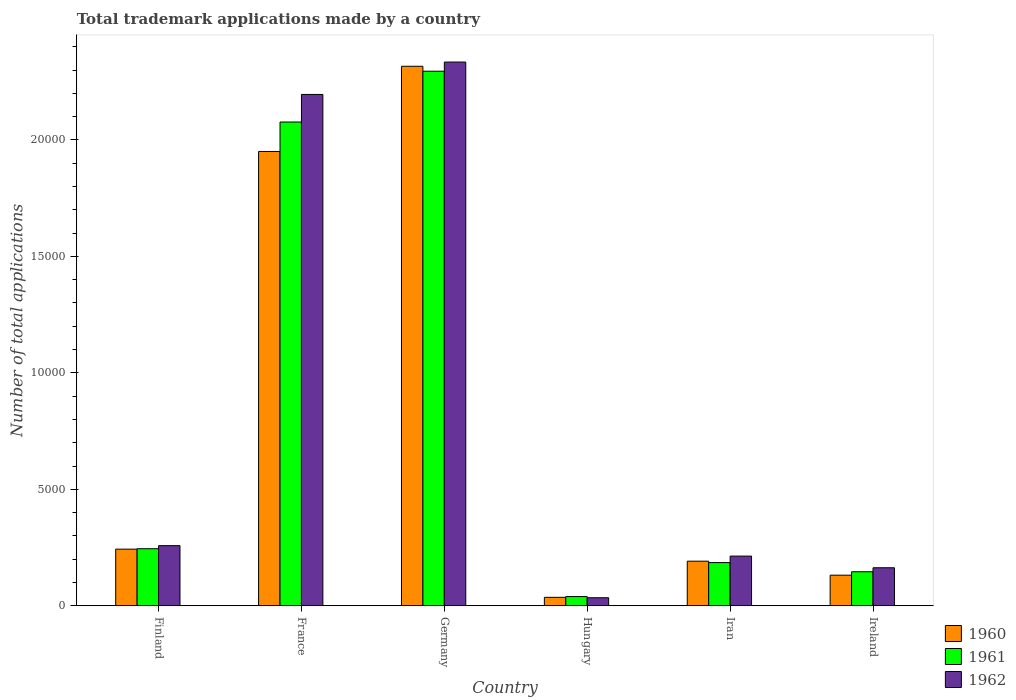Are the number of bars per tick equal to the number of legend labels?
Give a very brief answer. Yes. Are the number of bars on each tick of the X-axis equal?
Provide a short and direct response. Yes. How many bars are there on the 4th tick from the right?
Offer a very short reply. 3. What is the label of the 5th group of bars from the left?
Make the answer very short. Iran. What is the number of applications made by in 1962 in France?
Keep it short and to the point. 2.20e+04. Across all countries, what is the maximum number of applications made by in 1962?
Provide a short and direct response. 2.33e+04. Across all countries, what is the minimum number of applications made by in 1960?
Provide a succinct answer. 363. In which country was the number of applications made by in 1962 minimum?
Offer a very short reply. Hungary. What is the total number of applications made by in 1961 in the graph?
Your answer should be compact. 4.99e+04. What is the difference between the number of applications made by in 1960 in Germany and that in Ireland?
Give a very brief answer. 2.18e+04. What is the difference between the number of applications made by in 1961 in Finland and the number of applications made by in 1960 in Iran?
Give a very brief answer. 535. What is the average number of applications made by in 1960 per country?
Your answer should be compact. 8114.83. What is the difference between the number of applications made by of/in 1962 and number of applications made by of/in 1961 in Finland?
Keep it short and to the point. 132. In how many countries, is the number of applications made by in 1960 greater than 7000?
Your response must be concise. 2. What is the ratio of the number of applications made by in 1961 in Iran to that in Ireland?
Give a very brief answer. 1.27. Is the difference between the number of applications made by in 1962 in Germany and Iran greater than the difference between the number of applications made by in 1961 in Germany and Iran?
Ensure brevity in your answer.  Yes. What is the difference between the highest and the second highest number of applications made by in 1961?
Give a very brief answer. 1.83e+04. What is the difference between the highest and the lowest number of applications made by in 1960?
Make the answer very short. 2.28e+04. In how many countries, is the number of applications made by in 1960 greater than the average number of applications made by in 1960 taken over all countries?
Provide a short and direct response. 2. Is the sum of the number of applications made by in 1962 in France and Ireland greater than the maximum number of applications made by in 1960 across all countries?
Provide a short and direct response. Yes. What does the 2nd bar from the right in Iran represents?
Your response must be concise. 1961. Is it the case that in every country, the sum of the number of applications made by in 1962 and number of applications made by in 1960 is greater than the number of applications made by in 1961?
Make the answer very short. Yes. How many bars are there?
Provide a short and direct response. 18. Are all the bars in the graph horizontal?
Provide a succinct answer. No. Are the values on the major ticks of Y-axis written in scientific E-notation?
Your answer should be compact. No. Does the graph contain any zero values?
Keep it short and to the point. No. Does the graph contain grids?
Your answer should be very brief. No. Where does the legend appear in the graph?
Provide a short and direct response. Bottom right. How many legend labels are there?
Give a very brief answer. 3. What is the title of the graph?
Your answer should be compact. Total trademark applications made by a country. Does "2010" appear as one of the legend labels in the graph?
Your answer should be very brief. No. What is the label or title of the X-axis?
Your response must be concise. Country. What is the label or title of the Y-axis?
Your response must be concise. Number of total applications. What is the Number of total applications of 1960 in Finland?
Your answer should be very brief. 2432. What is the Number of total applications of 1961 in Finland?
Your response must be concise. 2450. What is the Number of total applications in 1962 in Finland?
Provide a short and direct response. 2582. What is the Number of total applications of 1960 in France?
Give a very brief answer. 1.95e+04. What is the Number of total applications in 1961 in France?
Provide a succinct answer. 2.08e+04. What is the Number of total applications of 1962 in France?
Your answer should be compact. 2.20e+04. What is the Number of total applications in 1960 in Germany?
Provide a succinct answer. 2.32e+04. What is the Number of total applications in 1961 in Germany?
Your response must be concise. 2.29e+04. What is the Number of total applications of 1962 in Germany?
Your answer should be compact. 2.33e+04. What is the Number of total applications in 1960 in Hungary?
Make the answer very short. 363. What is the Number of total applications of 1961 in Hungary?
Offer a terse response. 396. What is the Number of total applications of 1962 in Hungary?
Keep it short and to the point. 346. What is the Number of total applications of 1960 in Iran?
Offer a very short reply. 1915. What is the Number of total applications in 1961 in Iran?
Your answer should be compact. 1854. What is the Number of total applications in 1962 in Iran?
Offer a terse response. 2134. What is the Number of total applications in 1960 in Ireland?
Provide a short and direct response. 1314. What is the Number of total applications of 1961 in Ireland?
Your answer should be very brief. 1461. What is the Number of total applications of 1962 in Ireland?
Your answer should be compact. 1633. Across all countries, what is the maximum Number of total applications of 1960?
Your response must be concise. 2.32e+04. Across all countries, what is the maximum Number of total applications of 1961?
Provide a succinct answer. 2.29e+04. Across all countries, what is the maximum Number of total applications in 1962?
Make the answer very short. 2.33e+04. Across all countries, what is the minimum Number of total applications of 1960?
Make the answer very short. 363. Across all countries, what is the minimum Number of total applications in 1961?
Give a very brief answer. 396. Across all countries, what is the minimum Number of total applications in 1962?
Provide a short and direct response. 346. What is the total Number of total applications of 1960 in the graph?
Provide a short and direct response. 4.87e+04. What is the total Number of total applications of 1961 in the graph?
Your response must be concise. 4.99e+04. What is the total Number of total applications of 1962 in the graph?
Provide a succinct answer. 5.20e+04. What is the difference between the Number of total applications in 1960 in Finland and that in France?
Make the answer very short. -1.71e+04. What is the difference between the Number of total applications of 1961 in Finland and that in France?
Offer a very short reply. -1.83e+04. What is the difference between the Number of total applications of 1962 in Finland and that in France?
Provide a short and direct response. -1.94e+04. What is the difference between the Number of total applications of 1960 in Finland and that in Germany?
Your answer should be very brief. -2.07e+04. What is the difference between the Number of total applications of 1961 in Finland and that in Germany?
Make the answer very short. -2.05e+04. What is the difference between the Number of total applications of 1962 in Finland and that in Germany?
Keep it short and to the point. -2.08e+04. What is the difference between the Number of total applications in 1960 in Finland and that in Hungary?
Your response must be concise. 2069. What is the difference between the Number of total applications of 1961 in Finland and that in Hungary?
Provide a succinct answer. 2054. What is the difference between the Number of total applications of 1962 in Finland and that in Hungary?
Your answer should be very brief. 2236. What is the difference between the Number of total applications of 1960 in Finland and that in Iran?
Ensure brevity in your answer.  517. What is the difference between the Number of total applications in 1961 in Finland and that in Iran?
Provide a succinct answer. 596. What is the difference between the Number of total applications of 1962 in Finland and that in Iran?
Offer a terse response. 448. What is the difference between the Number of total applications in 1960 in Finland and that in Ireland?
Your answer should be very brief. 1118. What is the difference between the Number of total applications in 1961 in Finland and that in Ireland?
Make the answer very short. 989. What is the difference between the Number of total applications of 1962 in Finland and that in Ireland?
Provide a succinct answer. 949. What is the difference between the Number of total applications in 1960 in France and that in Germany?
Make the answer very short. -3657. What is the difference between the Number of total applications of 1961 in France and that in Germany?
Make the answer very short. -2181. What is the difference between the Number of total applications in 1962 in France and that in Germany?
Provide a short and direct response. -1390. What is the difference between the Number of total applications of 1960 in France and that in Hungary?
Your response must be concise. 1.91e+04. What is the difference between the Number of total applications of 1961 in France and that in Hungary?
Ensure brevity in your answer.  2.04e+04. What is the difference between the Number of total applications of 1962 in France and that in Hungary?
Provide a succinct answer. 2.16e+04. What is the difference between the Number of total applications in 1960 in France and that in Iran?
Ensure brevity in your answer.  1.76e+04. What is the difference between the Number of total applications of 1961 in France and that in Iran?
Make the answer very short. 1.89e+04. What is the difference between the Number of total applications of 1962 in France and that in Iran?
Offer a terse response. 1.98e+04. What is the difference between the Number of total applications in 1960 in France and that in Ireland?
Give a very brief answer. 1.82e+04. What is the difference between the Number of total applications of 1961 in France and that in Ireland?
Ensure brevity in your answer.  1.93e+04. What is the difference between the Number of total applications of 1962 in France and that in Ireland?
Make the answer very short. 2.03e+04. What is the difference between the Number of total applications in 1960 in Germany and that in Hungary?
Your answer should be very brief. 2.28e+04. What is the difference between the Number of total applications of 1961 in Germany and that in Hungary?
Make the answer very short. 2.26e+04. What is the difference between the Number of total applications in 1962 in Germany and that in Hungary?
Your answer should be compact. 2.30e+04. What is the difference between the Number of total applications in 1960 in Germany and that in Iran?
Ensure brevity in your answer.  2.12e+04. What is the difference between the Number of total applications in 1961 in Germany and that in Iran?
Your response must be concise. 2.11e+04. What is the difference between the Number of total applications of 1962 in Germany and that in Iran?
Keep it short and to the point. 2.12e+04. What is the difference between the Number of total applications in 1960 in Germany and that in Ireland?
Your response must be concise. 2.18e+04. What is the difference between the Number of total applications of 1961 in Germany and that in Ireland?
Your answer should be very brief. 2.15e+04. What is the difference between the Number of total applications in 1962 in Germany and that in Ireland?
Offer a terse response. 2.17e+04. What is the difference between the Number of total applications in 1960 in Hungary and that in Iran?
Provide a short and direct response. -1552. What is the difference between the Number of total applications of 1961 in Hungary and that in Iran?
Provide a succinct answer. -1458. What is the difference between the Number of total applications of 1962 in Hungary and that in Iran?
Provide a short and direct response. -1788. What is the difference between the Number of total applications of 1960 in Hungary and that in Ireland?
Your response must be concise. -951. What is the difference between the Number of total applications of 1961 in Hungary and that in Ireland?
Make the answer very short. -1065. What is the difference between the Number of total applications of 1962 in Hungary and that in Ireland?
Give a very brief answer. -1287. What is the difference between the Number of total applications in 1960 in Iran and that in Ireland?
Give a very brief answer. 601. What is the difference between the Number of total applications of 1961 in Iran and that in Ireland?
Offer a very short reply. 393. What is the difference between the Number of total applications of 1962 in Iran and that in Ireland?
Offer a very short reply. 501. What is the difference between the Number of total applications of 1960 in Finland and the Number of total applications of 1961 in France?
Keep it short and to the point. -1.83e+04. What is the difference between the Number of total applications in 1960 in Finland and the Number of total applications in 1962 in France?
Offer a very short reply. -1.95e+04. What is the difference between the Number of total applications of 1961 in Finland and the Number of total applications of 1962 in France?
Your answer should be compact. -1.95e+04. What is the difference between the Number of total applications of 1960 in Finland and the Number of total applications of 1961 in Germany?
Ensure brevity in your answer.  -2.05e+04. What is the difference between the Number of total applications in 1960 in Finland and the Number of total applications in 1962 in Germany?
Provide a succinct answer. -2.09e+04. What is the difference between the Number of total applications in 1961 in Finland and the Number of total applications in 1962 in Germany?
Provide a short and direct response. -2.09e+04. What is the difference between the Number of total applications in 1960 in Finland and the Number of total applications in 1961 in Hungary?
Your answer should be very brief. 2036. What is the difference between the Number of total applications in 1960 in Finland and the Number of total applications in 1962 in Hungary?
Ensure brevity in your answer.  2086. What is the difference between the Number of total applications in 1961 in Finland and the Number of total applications in 1962 in Hungary?
Keep it short and to the point. 2104. What is the difference between the Number of total applications of 1960 in Finland and the Number of total applications of 1961 in Iran?
Provide a succinct answer. 578. What is the difference between the Number of total applications of 1960 in Finland and the Number of total applications of 1962 in Iran?
Provide a succinct answer. 298. What is the difference between the Number of total applications of 1961 in Finland and the Number of total applications of 1962 in Iran?
Your answer should be compact. 316. What is the difference between the Number of total applications in 1960 in Finland and the Number of total applications in 1961 in Ireland?
Your answer should be very brief. 971. What is the difference between the Number of total applications of 1960 in Finland and the Number of total applications of 1962 in Ireland?
Your response must be concise. 799. What is the difference between the Number of total applications of 1961 in Finland and the Number of total applications of 1962 in Ireland?
Your answer should be compact. 817. What is the difference between the Number of total applications of 1960 in France and the Number of total applications of 1961 in Germany?
Offer a very short reply. -3445. What is the difference between the Number of total applications in 1960 in France and the Number of total applications in 1962 in Germany?
Your response must be concise. -3838. What is the difference between the Number of total applications of 1961 in France and the Number of total applications of 1962 in Germany?
Keep it short and to the point. -2574. What is the difference between the Number of total applications in 1960 in France and the Number of total applications in 1961 in Hungary?
Your response must be concise. 1.91e+04. What is the difference between the Number of total applications of 1960 in France and the Number of total applications of 1962 in Hungary?
Your response must be concise. 1.92e+04. What is the difference between the Number of total applications in 1961 in France and the Number of total applications in 1962 in Hungary?
Ensure brevity in your answer.  2.04e+04. What is the difference between the Number of total applications in 1960 in France and the Number of total applications in 1961 in Iran?
Offer a very short reply. 1.76e+04. What is the difference between the Number of total applications in 1960 in France and the Number of total applications in 1962 in Iran?
Make the answer very short. 1.74e+04. What is the difference between the Number of total applications of 1961 in France and the Number of total applications of 1962 in Iran?
Provide a succinct answer. 1.86e+04. What is the difference between the Number of total applications of 1960 in France and the Number of total applications of 1961 in Ireland?
Your response must be concise. 1.80e+04. What is the difference between the Number of total applications in 1960 in France and the Number of total applications in 1962 in Ireland?
Ensure brevity in your answer.  1.79e+04. What is the difference between the Number of total applications of 1961 in France and the Number of total applications of 1962 in Ireland?
Provide a short and direct response. 1.91e+04. What is the difference between the Number of total applications in 1960 in Germany and the Number of total applications in 1961 in Hungary?
Make the answer very short. 2.28e+04. What is the difference between the Number of total applications of 1960 in Germany and the Number of total applications of 1962 in Hungary?
Provide a succinct answer. 2.28e+04. What is the difference between the Number of total applications of 1961 in Germany and the Number of total applications of 1962 in Hungary?
Your answer should be very brief. 2.26e+04. What is the difference between the Number of total applications in 1960 in Germany and the Number of total applications in 1961 in Iran?
Your response must be concise. 2.13e+04. What is the difference between the Number of total applications of 1960 in Germany and the Number of total applications of 1962 in Iran?
Give a very brief answer. 2.10e+04. What is the difference between the Number of total applications in 1961 in Germany and the Number of total applications in 1962 in Iran?
Ensure brevity in your answer.  2.08e+04. What is the difference between the Number of total applications in 1960 in Germany and the Number of total applications in 1961 in Ireland?
Keep it short and to the point. 2.17e+04. What is the difference between the Number of total applications of 1960 in Germany and the Number of total applications of 1962 in Ireland?
Provide a succinct answer. 2.15e+04. What is the difference between the Number of total applications of 1961 in Germany and the Number of total applications of 1962 in Ireland?
Provide a succinct answer. 2.13e+04. What is the difference between the Number of total applications in 1960 in Hungary and the Number of total applications in 1961 in Iran?
Provide a succinct answer. -1491. What is the difference between the Number of total applications of 1960 in Hungary and the Number of total applications of 1962 in Iran?
Provide a succinct answer. -1771. What is the difference between the Number of total applications in 1961 in Hungary and the Number of total applications in 1962 in Iran?
Give a very brief answer. -1738. What is the difference between the Number of total applications of 1960 in Hungary and the Number of total applications of 1961 in Ireland?
Offer a terse response. -1098. What is the difference between the Number of total applications in 1960 in Hungary and the Number of total applications in 1962 in Ireland?
Keep it short and to the point. -1270. What is the difference between the Number of total applications of 1961 in Hungary and the Number of total applications of 1962 in Ireland?
Provide a short and direct response. -1237. What is the difference between the Number of total applications of 1960 in Iran and the Number of total applications of 1961 in Ireland?
Offer a very short reply. 454. What is the difference between the Number of total applications of 1960 in Iran and the Number of total applications of 1962 in Ireland?
Your answer should be compact. 282. What is the difference between the Number of total applications of 1961 in Iran and the Number of total applications of 1962 in Ireland?
Make the answer very short. 221. What is the average Number of total applications in 1960 per country?
Provide a short and direct response. 8114.83. What is the average Number of total applications in 1961 per country?
Your response must be concise. 8313. What is the average Number of total applications in 1962 per country?
Provide a succinct answer. 8664.83. What is the difference between the Number of total applications in 1960 and Number of total applications in 1962 in Finland?
Make the answer very short. -150. What is the difference between the Number of total applications of 1961 and Number of total applications of 1962 in Finland?
Provide a succinct answer. -132. What is the difference between the Number of total applications in 1960 and Number of total applications in 1961 in France?
Ensure brevity in your answer.  -1264. What is the difference between the Number of total applications in 1960 and Number of total applications in 1962 in France?
Provide a short and direct response. -2448. What is the difference between the Number of total applications in 1961 and Number of total applications in 1962 in France?
Keep it short and to the point. -1184. What is the difference between the Number of total applications in 1960 and Number of total applications in 1961 in Germany?
Ensure brevity in your answer.  212. What is the difference between the Number of total applications of 1960 and Number of total applications of 1962 in Germany?
Provide a short and direct response. -181. What is the difference between the Number of total applications in 1961 and Number of total applications in 1962 in Germany?
Keep it short and to the point. -393. What is the difference between the Number of total applications of 1960 and Number of total applications of 1961 in Hungary?
Ensure brevity in your answer.  -33. What is the difference between the Number of total applications in 1960 and Number of total applications in 1962 in Hungary?
Your response must be concise. 17. What is the difference between the Number of total applications of 1960 and Number of total applications of 1961 in Iran?
Give a very brief answer. 61. What is the difference between the Number of total applications in 1960 and Number of total applications in 1962 in Iran?
Offer a very short reply. -219. What is the difference between the Number of total applications of 1961 and Number of total applications of 1962 in Iran?
Offer a terse response. -280. What is the difference between the Number of total applications in 1960 and Number of total applications in 1961 in Ireland?
Ensure brevity in your answer.  -147. What is the difference between the Number of total applications of 1960 and Number of total applications of 1962 in Ireland?
Offer a terse response. -319. What is the difference between the Number of total applications in 1961 and Number of total applications in 1962 in Ireland?
Make the answer very short. -172. What is the ratio of the Number of total applications of 1960 in Finland to that in France?
Provide a short and direct response. 0.12. What is the ratio of the Number of total applications in 1961 in Finland to that in France?
Provide a succinct answer. 0.12. What is the ratio of the Number of total applications in 1962 in Finland to that in France?
Provide a succinct answer. 0.12. What is the ratio of the Number of total applications in 1960 in Finland to that in Germany?
Give a very brief answer. 0.1. What is the ratio of the Number of total applications of 1961 in Finland to that in Germany?
Provide a short and direct response. 0.11. What is the ratio of the Number of total applications of 1962 in Finland to that in Germany?
Provide a succinct answer. 0.11. What is the ratio of the Number of total applications of 1960 in Finland to that in Hungary?
Offer a very short reply. 6.7. What is the ratio of the Number of total applications of 1961 in Finland to that in Hungary?
Give a very brief answer. 6.19. What is the ratio of the Number of total applications of 1962 in Finland to that in Hungary?
Give a very brief answer. 7.46. What is the ratio of the Number of total applications in 1960 in Finland to that in Iran?
Provide a short and direct response. 1.27. What is the ratio of the Number of total applications of 1961 in Finland to that in Iran?
Provide a succinct answer. 1.32. What is the ratio of the Number of total applications in 1962 in Finland to that in Iran?
Ensure brevity in your answer.  1.21. What is the ratio of the Number of total applications of 1960 in Finland to that in Ireland?
Offer a very short reply. 1.85. What is the ratio of the Number of total applications of 1961 in Finland to that in Ireland?
Keep it short and to the point. 1.68. What is the ratio of the Number of total applications of 1962 in Finland to that in Ireland?
Your response must be concise. 1.58. What is the ratio of the Number of total applications of 1960 in France to that in Germany?
Ensure brevity in your answer.  0.84. What is the ratio of the Number of total applications of 1961 in France to that in Germany?
Your answer should be very brief. 0.91. What is the ratio of the Number of total applications in 1962 in France to that in Germany?
Ensure brevity in your answer.  0.94. What is the ratio of the Number of total applications of 1960 in France to that in Hungary?
Make the answer very short. 53.73. What is the ratio of the Number of total applications in 1961 in France to that in Hungary?
Ensure brevity in your answer.  52.44. What is the ratio of the Number of total applications of 1962 in France to that in Hungary?
Make the answer very short. 63.45. What is the ratio of the Number of total applications in 1960 in France to that in Iran?
Offer a very short reply. 10.18. What is the ratio of the Number of total applications in 1961 in France to that in Iran?
Your response must be concise. 11.2. What is the ratio of the Number of total applications of 1962 in France to that in Iran?
Provide a succinct answer. 10.29. What is the ratio of the Number of total applications of 1960 in France to that in Ireland?
Ensure brevity in your answer.  14.84. What is the ratio of the Number of total applications of 1961 in France to that in Ireland?
Make the answer very short. 14.21. What is the ratio of the Number of total applications of 1962 in France to that in Ireland?
Your answer should be very brief. 13.44. What is the ratio of the Number of total applications of 1960 in Germany to that in Hungary?
Make the answer very short. 63.8. What is the ratio of the Number of total applications of 1961 in Germany to that in Hungary?
Offer a terse response. 57.95. What is the ratio of the Number of total applications in 1962 in Germany to that in Hungary?
Give a very brief answer. 67.46. What is the ratio of the Number of total applications of 1960 in Germany to that in Iran?
Your response must be concise. 12.09. What is the ratio of the Number of total applications in 1961 in Germany to that in Iran?
Your answer should be compact. 12.38. What is the ratio of the Number of total applications of 1962 in Germany to that in Iran?
Make the answer very short. 10.94. What is the ratio of the Number of total applications of 1960 in Germany to that in Ireland?
Offer a very short reply. 17.63. What is the ratio of the Number of total applications of 1961 in Germany to that in Ireland?
Your answer should be compact. 15.71. What is the ratio of the Number of total applications of 1962 in Germany to that in Ireland?
Ensure brevity in your answer.  14.29. What is the ratio of the Number of total applications of 1960 in Hungary to that in Iran?
Your answer should be very brief. 0.19. What is the ratio of the Number of total applications in 1961 in Hungary to that in Iran?
Ensure brevity in your answer.  0.21. What is the ratio of the Number of total applications in 1962 in Hungary to that in Iran?
Keep it short and to the point. 0.16. What is the ratio of the Number of total applications of 1960 in Hungary to that in Ireland?
Your answer should be very brief. 0.28. What is the ratio of the Number of total applications of 1961 in Hungary to that in Ireland?
Your answer should be very brief. 0.27. What is the ratio of the Number of total applications of 1962 in Hungary to that in Ireland?
Your response must be concise. 0.21. What is the ratio of the Number of total applications of 1960 in Iran to that in Ireland?
Your answer should be compact. 1.46. What is the ratio of the Number of total applications of 1961 in Iran to that in Ireland?
Offer a terse response. 1.27. What is the ratio of the Number of total applications in 1962 in Iran to that in Ireland?
Make the answer very short. 1.31. What is the difference between the highest and the second highest Number of total applications of 1960?
Provide a succinct answer. 3657. What is the difference between the highest and the second highest Number of total applications of 1961?
Provide a short and direct response. 2181. What is the difference between the highest and the second highest Number of total applications of 1962?
Offer a very short reply. 1390. What is the difference between the highest and the lowest Number of total applications in 1960?
Give a very brief answer. 2.28e+04. What is the difference between the highest and the lowest Number of total applications in 1961?
Keep it short and to the point. 2.26e+04. What is the difference between the highest and the lowest Number of total applications in 1962?
Your answer should be compact. 2.30e+04. 